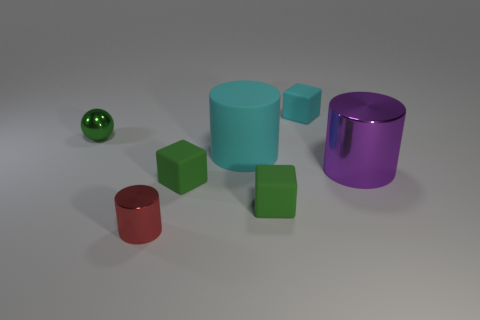There is a large object that is the same material as the green ball; what color is it?
Ensure brevity in your answer.  Purple. The tiny metallic thing that is in front of the thing that is left of the cylinder in front of the big purple cylinder is what color?
Offer a very short reply. Red. What number of blocks are green matte things or large rubber objects?
Give a very brief answer. 2. What material is the tiny cube that is the same color as the matte cylinder?
Provide a succinct answer. Rubber. Does the small shiny ball have the same color as the big cylinder on the left side of the small cyan block?
Offer a terse response. No. What is the color of the tiny shiny sphere?
Your answer should be very brief. Green. What number of objects are either tiny metallic things or matte cylinders?
Keep it short and to the point. 3. There is a purple cylinder that is the same size as the cyan matte cylinder; what material is it?
Provide a short and direct response. Metal. How big is the green thing that is to the left of the red cylinder?
Your answer should be very brief. Small. What is the material of the big cyan cylinder?
Offer a very short reply. Rubber. 